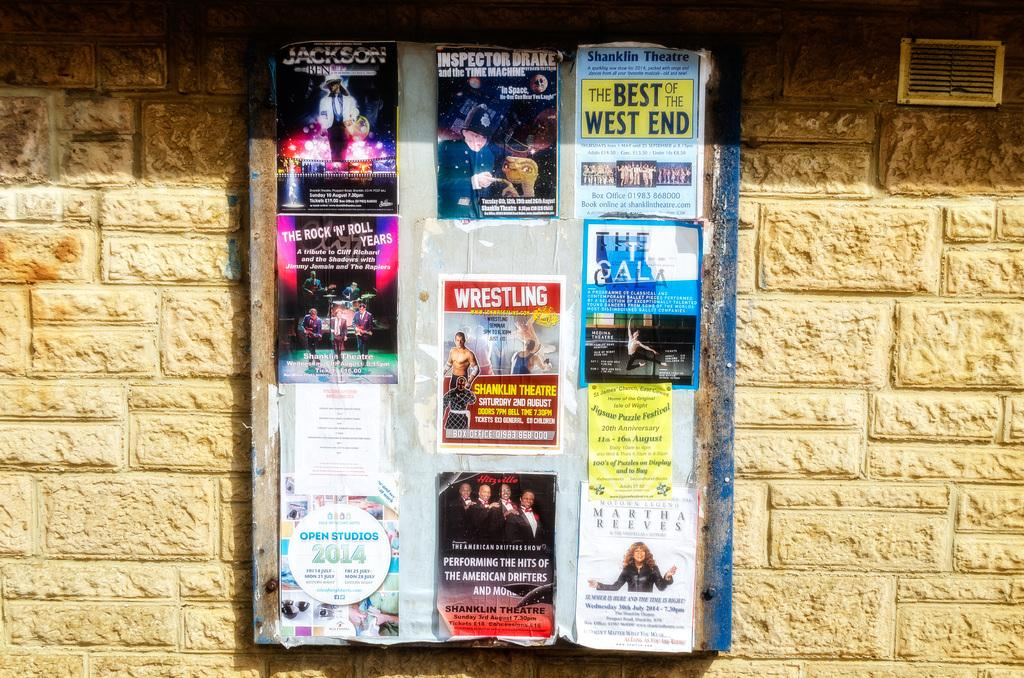Provide a one-sentence caption for the provided image. A bulletin board with posters for shows like Jackson and Inspector Drake. 